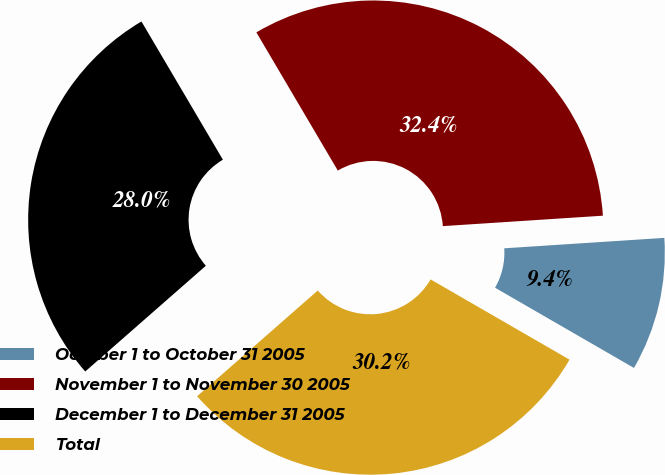<chart> <loc_0><loc_0><loc_500><loc_500><pie_chart><fcel>October 1 to October 31 2005<fcel>November 1 to November 30 2005<fcel>December 1 to December 31 2005<fcel>Total<nl><fcel>9.37%<fcel>32.44%<fcel>27.98%<fcel>30.21%<nl></chart> 